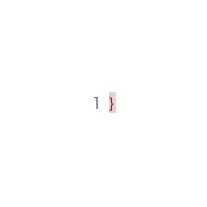<code> <loc_0><loc_0><loc_500><loc_500><_CSS_>}
</code> 